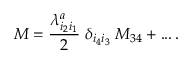Convert formula to latex. <formula><loc_0><loc_0><loc_500><loc_500>M = { \frac { \lambda _ { i _ { 2 } i _ { 1 } } ^ { a } } { 2 } } \, { \delta _ { i _ { 4 } i _ { 3 } } } \, M _ { 3 4 } + \dots \, .</formula> 